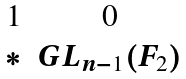Convert formula to latex. <formula><loc_0><loc_0><loc_500><loc_500>\begin{matrix} 1 & 0 \\ * & G L _ { n - 1 } ( F _ { 2 } ) \\ \end{matrix}</formula> 